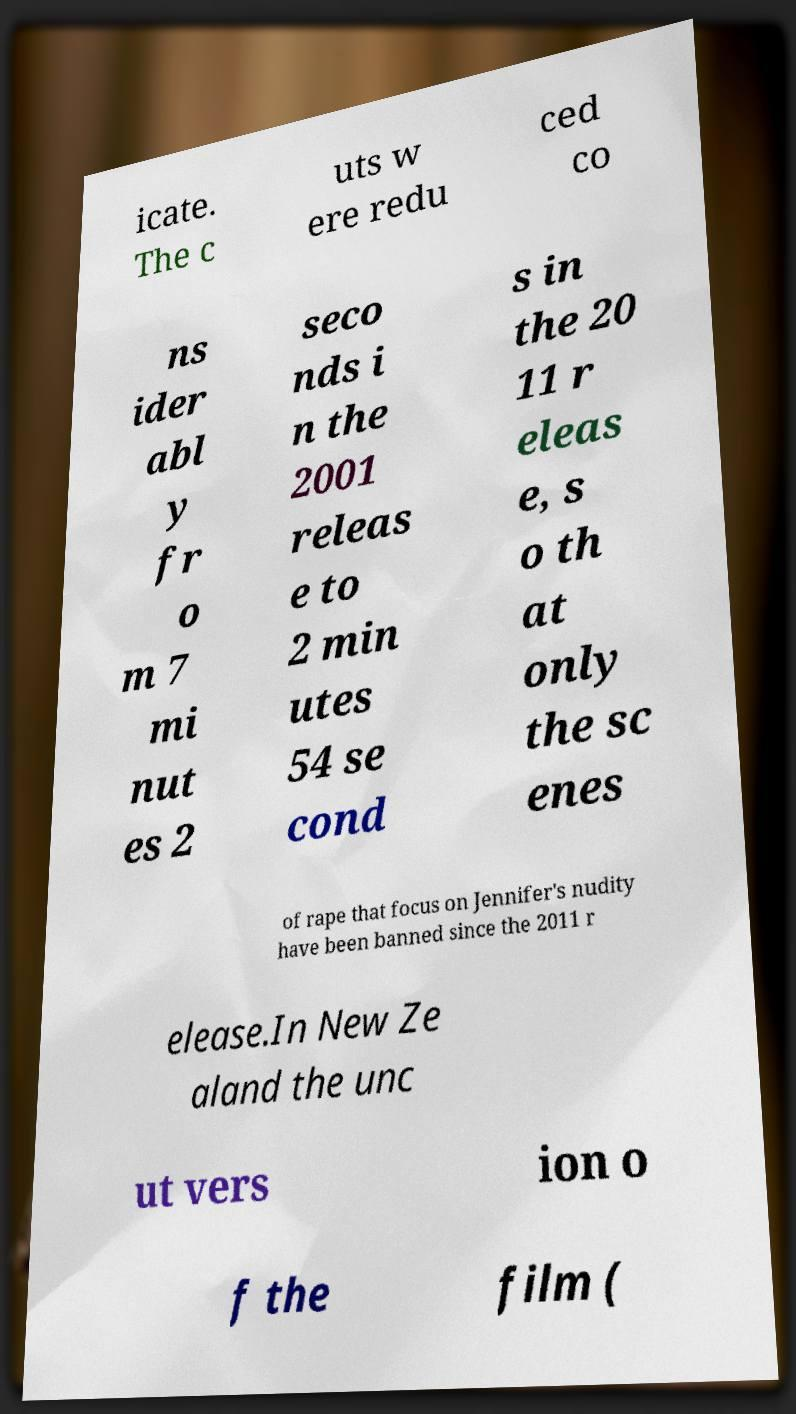I need the written content from this picture converted into text. Can you do that? icate. The c uts w ere redu ced co ns ider abl y fr o m 7 mi nut es 2 seco nds i n the 2001 releas e to 2 min utes 54 se cond s in the 20 11 r eleas e, s o th at only the sc enes of rape that focus on Jennifer's nudity have been banned since the 2011 r elease.In New Ze aland the unc ut vers ion o f the film ( 